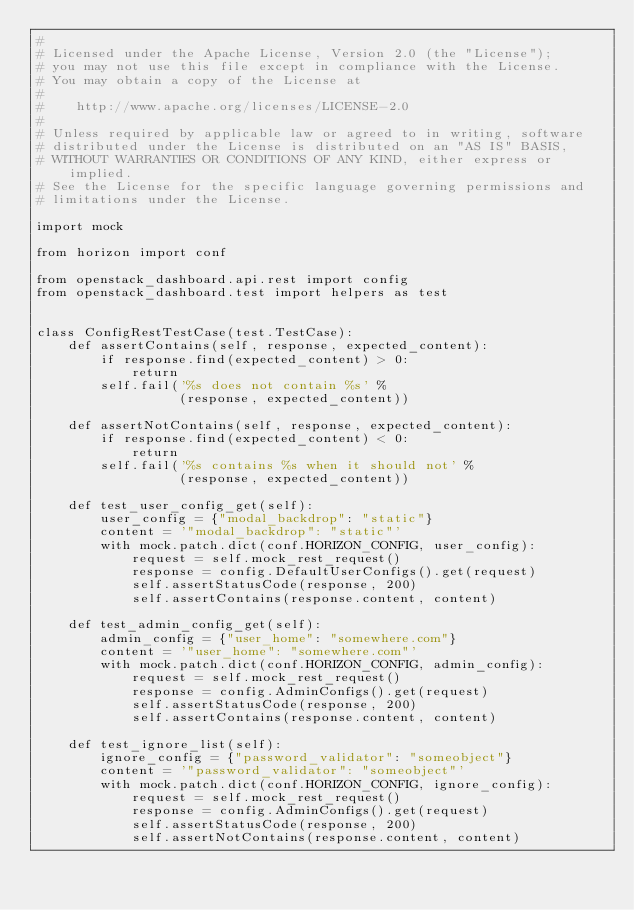<code> <loc_0><loc_0><loc_500><loc_500><_Python_>#
# Licensed under the Apache License, Version 2.0 (the "License");
# you may not use this file except in compliance with the License.
# You may obtain a copy of the License at
#
#    http://www.apache.org/licenses/LICENSE-2.0
#
# Unless required by applicable law or agreed to in writing, software
# distributed under the License is distributed on an "AS IS" BASIS,
# WITHOUT WARRANTIES OR CONDITIONS OF ANY KIND, either express or implied.
# See the License for the specific language governing permissions and
# limitations under the License.

import mock

from horizon import conf

from openstack_dashboard.api.rest import config
from openstack_dashboard.test import helpers as test


class ConfigRestTestCase(test.TestCase):
    def assertContains(self, response, expected_content):
        if response.find(expected_content) > 0:
            return
        self.fail('%s does not contain %s' %
                  (response, expected_content))

    def assertNotContains(self, response, expected_content):
        if response.find(expected_content) < 0:
            return
        self.fail('%s contains %s when it should not' %
                  (response, expected_content))

    def test_user_config_get(self):
        user_config = {"modal_backdrop": "static"}
        content = '"modal_backdrop": "static"'
        with mock.patch.dict(conf.HORIZON_CONFIG, user_config):
            request = self.mock_rest_request()
            response = config.DefaultUserConfigs().get(request)
            self.assertStatusCode(response, 200)
            self.assertContains(response.content, content)

    def test_admin_config_get(self):
        admin_config = {"user_home": "somewhere.com"}
        content = '"user_home": "somewhere.com"'
        with mock.patch.dict(conf.HORIZON_CONFIG, admin_config):
            request = self.mock_rest_request()
            response = config.AdminConfigs().get(request)
            self.assertStatusCode(response, 200)
            self.assertContains(response.content, content)

    def test_ignore_list(self):
        ignore_config = {"password_validator": "someobject"}
        content = '"password_validator": "someobject"'
        with mock.patch.dict(conf.HORIZON_CONFIG, ignore_config):
            request = self.mock_rest_request()
            response = config.AdminConfigs().get(request)
            self.assertStatusCode(response, 200)
            self.assertNotContains(response.content, content)
</code> 